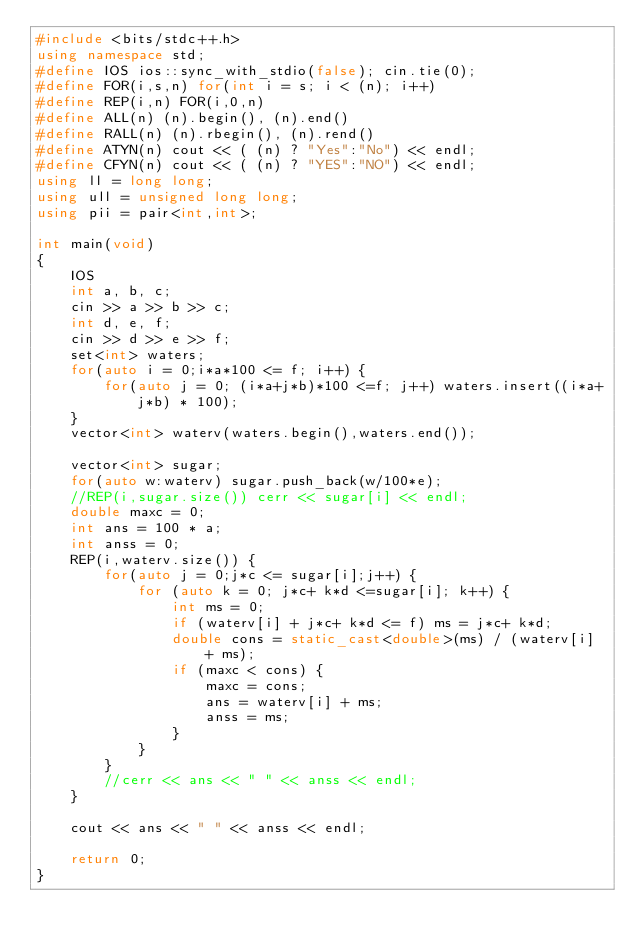<code> <loc_0><loc_0><loc_500><loc_500><_C++_>#include <bits/stdc++.h>
using namespace std;
#define IOS ios::sync_with_stdio(false); cin.tie(0);
#define FOR(i,s,n) for(int i = s; i < (n); i++)
#define REP(i,n) FOR(i,0,n)
#define ALL(n) (n).begin(), (n).end()
#define RALL(n) (n).rbegin(), (n).rend()
#define ATYN(n) cout << ( (n) ? "Yes":"No") << endl;
#define CFYN(n) cout << ( (n) ? "YES":"NO") << endl;
using ll = long long;
using ull = unsigned long long;
using pii = pair<int,int>;

int main(void)
{
    IOS
    int a, b, c;
    cin >> a >> b >> c;
    int d, e, f;
    cin >> d >> e >> f;
    set<int> waters;
    for(auto i = 0;i*a*100 <= f; i++) {
        for(auto j = 0; (i*a+j*b)*100 <=f; j++) waters.insert((i*a+j*b) * 100);
    }
    vector<int> waterv(waters.begin(),waters.end());
    
    vector<int> sugar;
    for(auto w:waterv) sugar.push_back(w/100*e);
    //REP(i,sugar.size()) cerr << sugar[i] << endl;
    double maxc = 0;
    int ans = 100 * a;
    int anss = 0;
    REP(i,waterv.size()) {
        for(auto j = 0;j*c <= sugar[i];j++) {
            for (auto k = 0; j*c+ k*d <=sugar[i]; k++) {
                int ms = 0;
                if (waterv[i] + j*c+ k*d <= f) ms = j*c+ k*d;
                double cons = static_cast<double>(ms) / (waterv[i] + ms);
                if (maxc < cons) {
                    maxc = cons;
                    ans = waterv[i] + ms;
                    anss = ms;
                }
            }
        }
        //cerr << ans << " " << anss << endl;
    }

    cout << ans << " " << anss << endl;

    return 0;
}</code> 